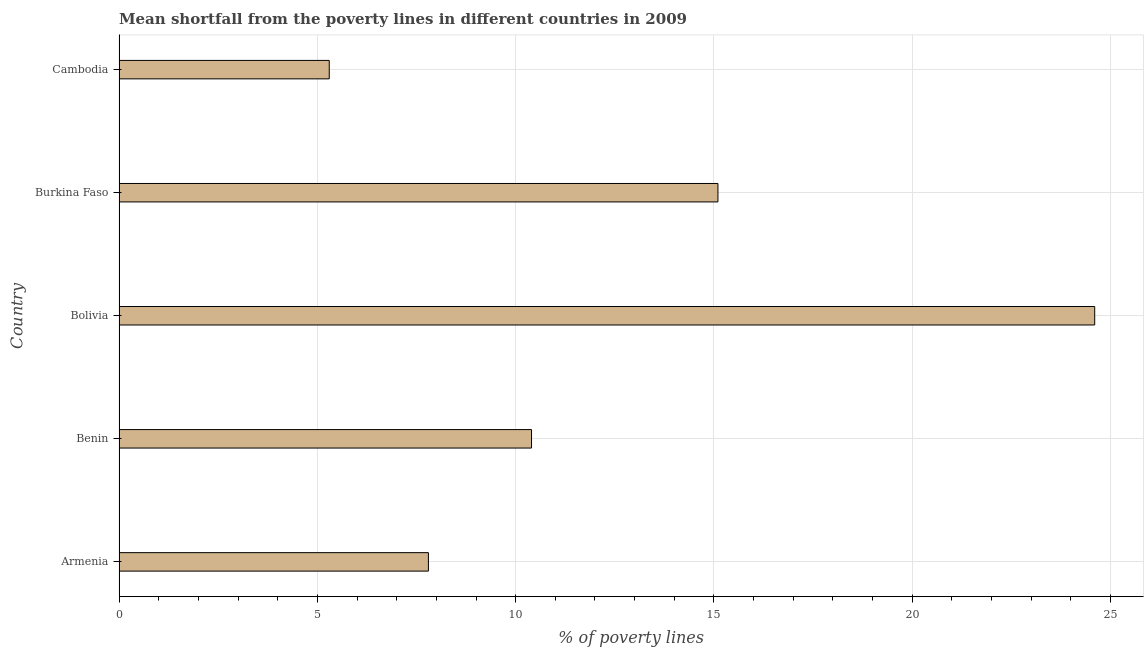What is the title of the graph?
Keep it short and to the point. Mean shortfall from the poverty lines in different countries in 2009. What is the label or title of the X-axis?
Give a very brief answer. % of poverty lines. Across all countries, what is the maximum poverty gap at national poverty lines?
Keep it short and to the point. 24.6. Across all countries, what is the minimum poverty gap at national poverty lines?
Keep it short and to the point. 5.3. In which country was the poverty gap at national poverty lines maximum?
Give a very brief answer. Bolivia. In which country was the poverty gap at national poverty lines minimum?
Your answer should be compact. Cambodia. What is the sum of the poverty gap at national poverty lines?
Your answer should be very brief. 63.2. What is the difference between the poverty gap at national poverty lines in Bolivia and Cambodia?
Make the answer very short. 19.3. What is the average poverty gap at national poverty lines per country?
Ensure brevity in your answer.  12.64. What is the median poverty gap at national poverty lines?
Provide a short and direct response. 10.4. In how many countries, is the poverty gap at national poverty lines greater than 12 %?
Provide a short and direct response. 2. What is the ratio of the poverty gap at national poverty lines in Bolivia to that in Burkina Faso?
Provide a short and direct response. 1.63. Is the poverty gap at national poverty lines in Benin less than that in Bolivia?
Provide a succinct answer. Yes. Is the difference between the poverty gap at national poverty lines in Armenia and Burkina Faso greater than the difference between any two countries?
Give a very brief answer. No. What is the difference between the highest and the lowest poverty gap at national poverty lines?
Your answer should be compact. 19.3. What is the difference between two consecutive major ticks on the X-axis?
Offer a very short reply. 5. Are the values on the major ticks of X-axis written in scientific E-notation?
Your answer should be very brief. No. What is the % of poverty lines in Benin?
Offer a terse response. 10.4. What is the % of poverty lines in Bolivia?
Keep it short and to the point. 24.6. What is the difference between the % of poverty lines in Armenia and Benin?
Offer a very short reply. -2.6. What is the difference between the % of poverty lines in Armenia and Bolivia?
Offer a terse response. -16.8. What is the difference between the % of poverty lines in Benin and Bolivia?
Your answer should be very brief. -14.2. What is the difference between the % of poverty lines in Benin and Burkina Faso?
Your answer should be very brief. -4.7. What is the difference between the % of poverty lines in Benin and Cambodia?
Provide a succinct answer. 5.1. What is the difference between the % of poverty lines in Bolivia and Cambodia?
Your answer should be very brief. 19.3. What is the ratio of the % of poverty lines in Armenia to that in Bolivia?
Your answer should be compact. 0.32. What is the ratio of the % of poverty lines in Armenia to that in Burkina Faso?
Your answer should be compact. 0.52. What is the ratio of the % of poverty lines in Armenia to that in Cambodia?
Your answer should be compact. 1.47. What is the ratio of the % of poverty lines in Benin to that in Bolivia?
Provide a short and direct response. 0.42. What is the ratio of the % of poverty lines in Benin to that in Burkina Faso?
Your response must be concise. 0.69. What is the ratio of the % of poverty lines in Benin to that in Cambodia?
Provide a short and direct response. 1.96. What is the ratio of the % of poverty lines in Bolivia to that in Burkina Faso?
Offer a very short reply. 1.63. What is the ratio of the % of poverty lines in Bolivia to that in Cambodia?
Offer a terse response. 4.64. What is the ratio of the % of poverty lines in Burkina Faso to that in Cambodia?
Give a very brief answer. 2.85. 